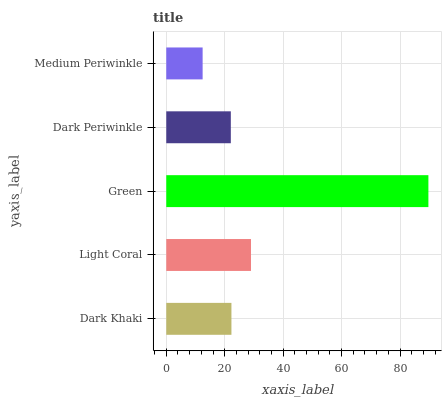Is Medium Periwinkle the minimum?
Answer yes or no. Yes. Is Green the maximum?
Answer yes or no. Yes. Is Light Coral the minimum?
Answer yes or no. No. Is Light Coral the maximum?
Answer yes or no. No. Is Light Coral greater than Dark Khaki?
Answer yes or no. Yes. Is Dark Khaki less than Light Coral?
Answer yes or no. Yes. Is Dark Khaki greater than Light Coral?
Answer yes or no. No. Is Light Coral less than Dark Khaki?
Answer yes or no. No. Is Dark Khaki the high median?
Answer yes or no. Yes. Is Dark Khaki the low median?
Answer yes or no. Yes. Is Medium Periwinkle the high median?
Answer yes or no. No. Is Dark Periwinkle the low median?
Answer yes or no. No. 